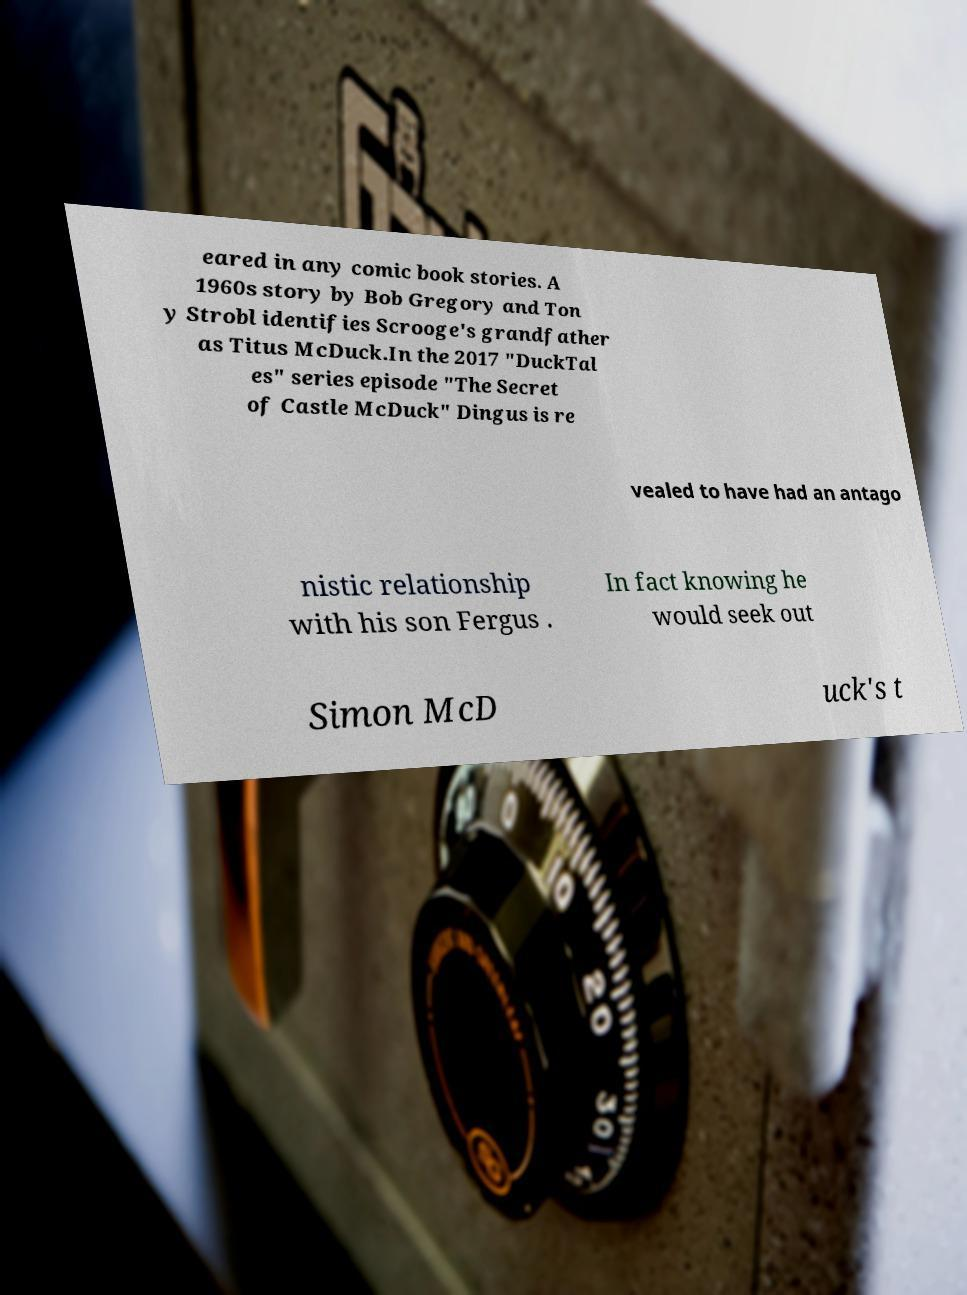Can you read and provide the text displayed in the image?This photo seems to have some interesting text. Can you extract and type it out for me? eared in any comic book stories. A 1960s story by Bob Gregory and Ton y Strobl identifies Scrooge's grandfather as Titus McDuck.In the 2017 "DuckTal es" series episode "The Secret of Castle McDuck" Dingus is re vealed to have had an antago nistic relationship with his son Fergus . In fact knowing he would seek out Simon McD uck's t 